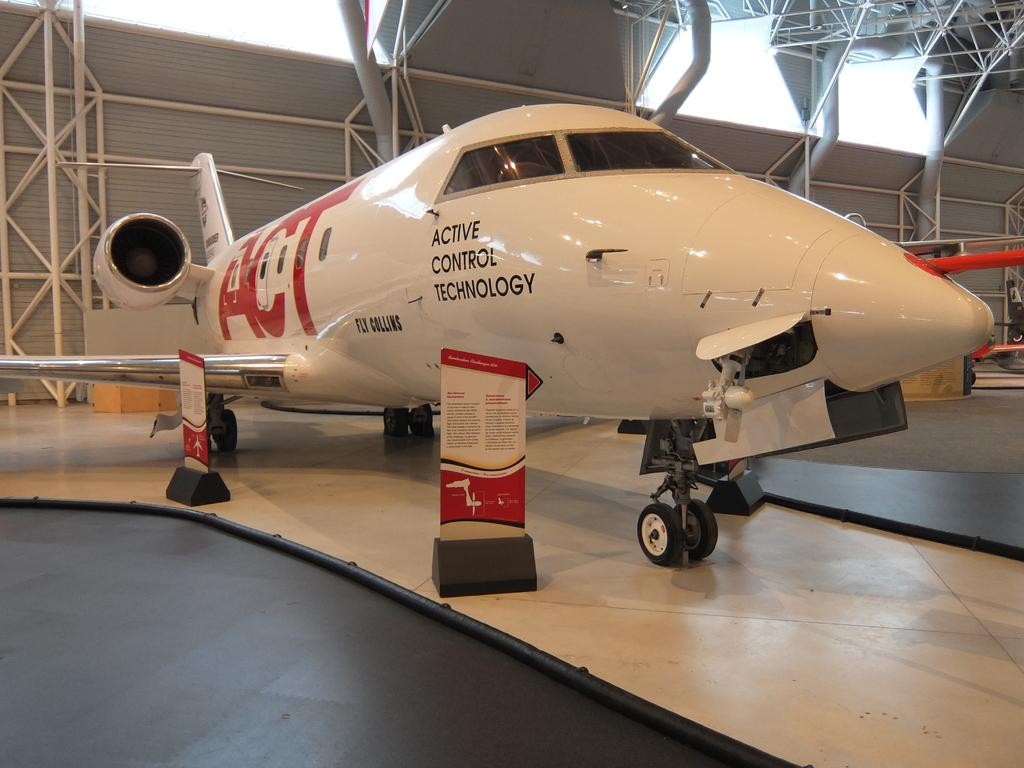<image>
Create a compact narrative representing the image presented. An airplane with Active Control Technology written on the side is displayed in a hangar. 